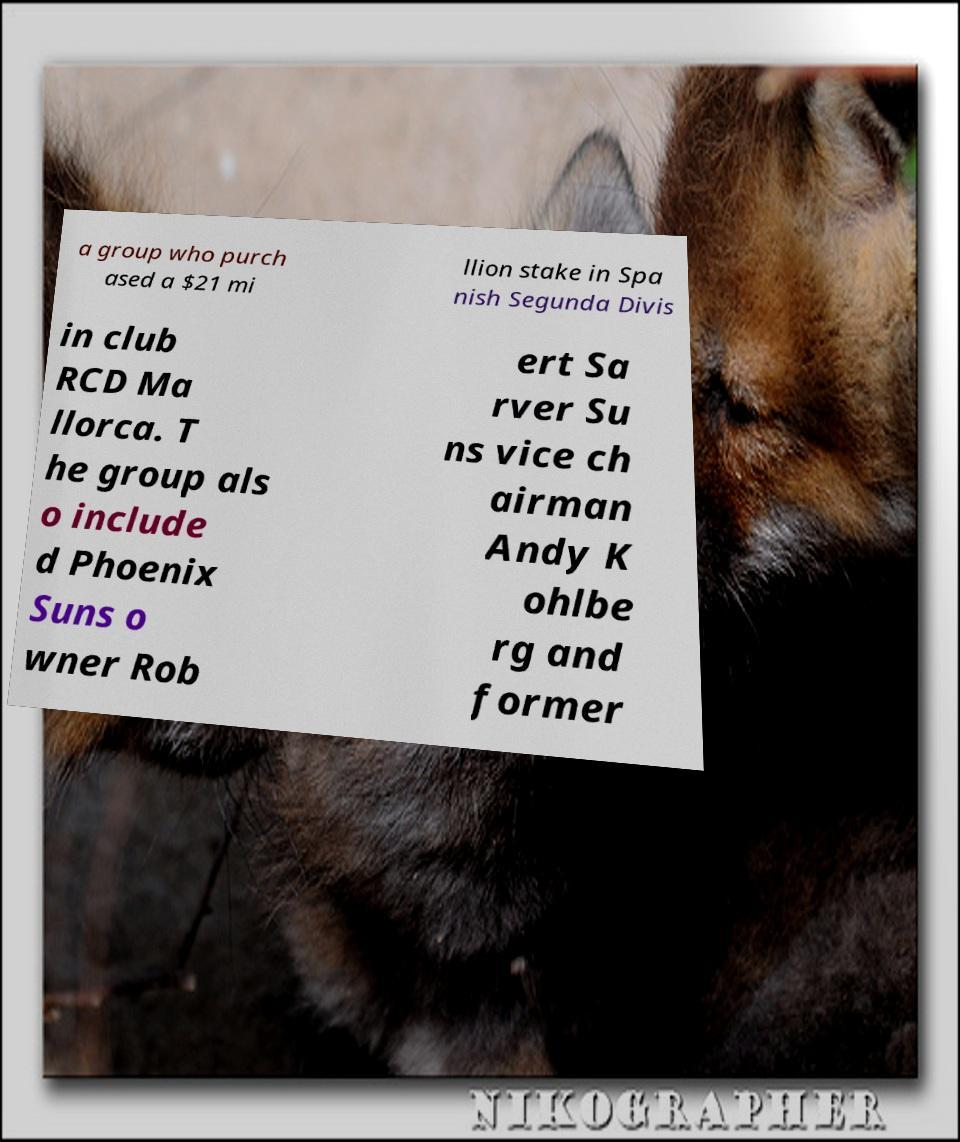For documentation purposes, I need the text within this image transcribed. Could you provide that? a group who purch ased a $21 mi llion stake in Spa nish Segunda Divis in club RCD Ma llorca. T he group als o include d Phoenix Suns o wner Rob ert Sa rver Su ns vice ch airman Andy K ohlbe rg and former 